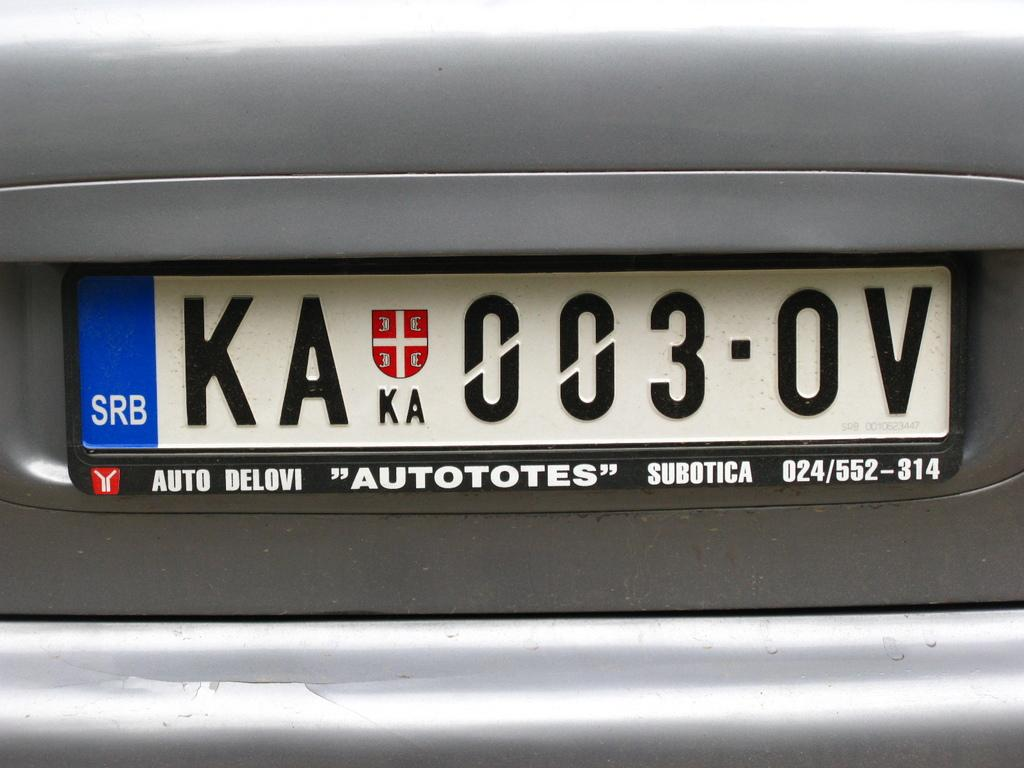Provide a one-sentence caption for the provided image. The back of a car with license plate number KA 003 OV. 